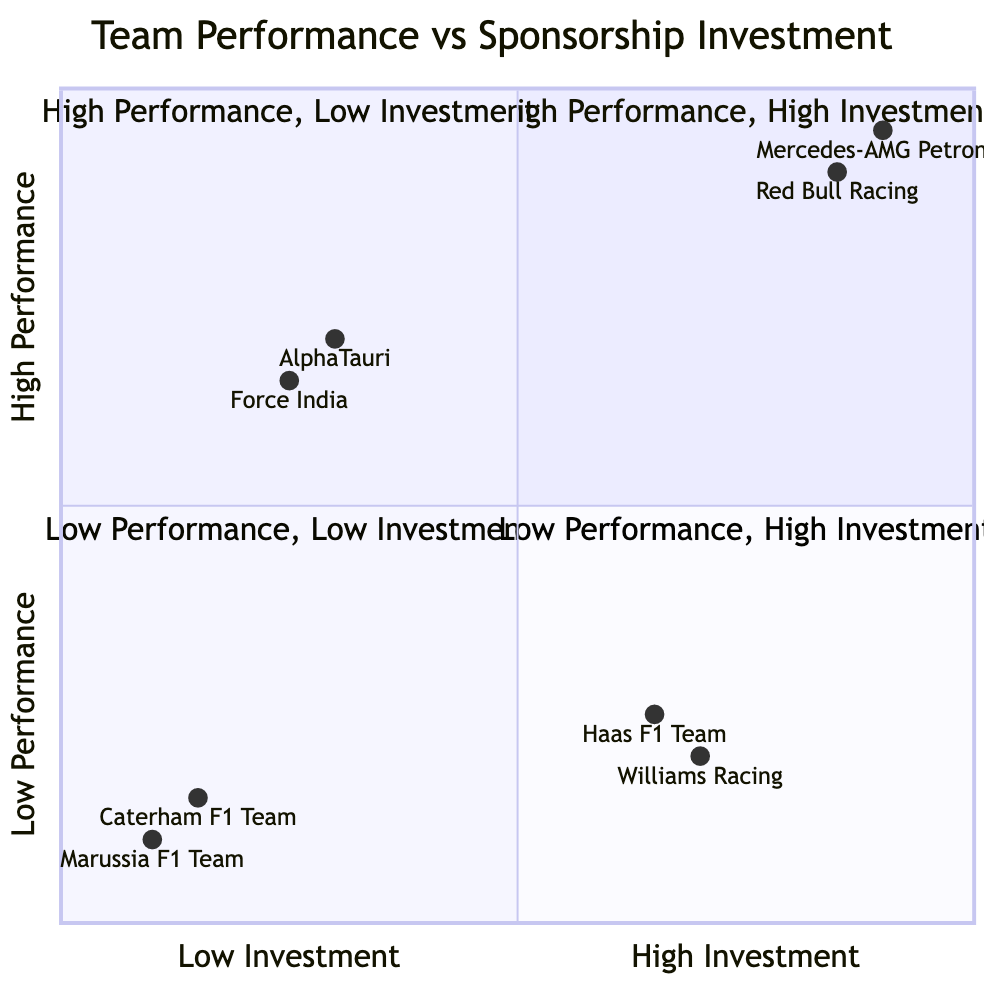What teams are in the "High Performance, High Investment" quadrant? The "High Performance, High Investment" quadrant contains the teams Mercedes-AMG Petronas and Red Bull Racing.
Answer: Mercedes-AMG Petronas, Red Bull Racing How many teams are in the "Low Performance, Low Investment" quadrant? The "Low Performance, Low Investment" quadrant has two teams: Marussia F1 Team and Caterham F1 Team.
Answer: 2 Which team has the highest sponsorship investment? Mercedes-AMG Petronas has the highest sponsorship investment as it is positioned in the "High Performance, High Investment" quadrant, indicating a strong association between performance and investment.
Answer: Mercedes-AMG Petronas What is the performance status of the Williams Racing team? Williams Racing is positioned in the "Low Performance, High Investment" quadrant, indicating it struggles in performance despite significant sponsorship.
Answer: Struggling Which team has occasional wins and frequently top-ten finishes? AlphaTauri is the team that achieves occasional wins and frequently has top-ten finishes, as indicated in the "High Performance, Low Investment" quadrant.
Answer: AlphaTauri How many teams are categorized as "Low Performance"? Two quadrants show "Low Performance": the "Low Performance, Low Investment" and "Low Performance, High Investment" quadrants. Combining both, there are four teams categorized as Low Performance: Williams Racing, Haas F1 Team, Marussia F1 Team, and Caterham F1 Team.
Answer: 4 What are the sponsors of the Haas F1 Team? The Haas F1 Team sponsors are Uralkali, Jack & Jones, and Alpinestars, as listed under the "Low Performance, High Investment" quadrant.
Answer: Uralkali, Jack & Jones, Alpinestars Which quadrant has teams that are struggling despite their sponsorship investment? The "Low Performance, High Investment" quadrant contains teams that are struggling despite their sponsorship investment, specifically Williams Racing and Haas F1 Team.
Answer: Low Performance, High Investment What can be inferred about the relationship between performance and investment for the AlphaTauri team? AlphaTauri is in the "High Performance, Low Investment" quadrant, suggesting that it has managed to achieve a good performance level with relatively low investment, which is a noteworthy outcome.
Answer: High Performance, Low Investment 